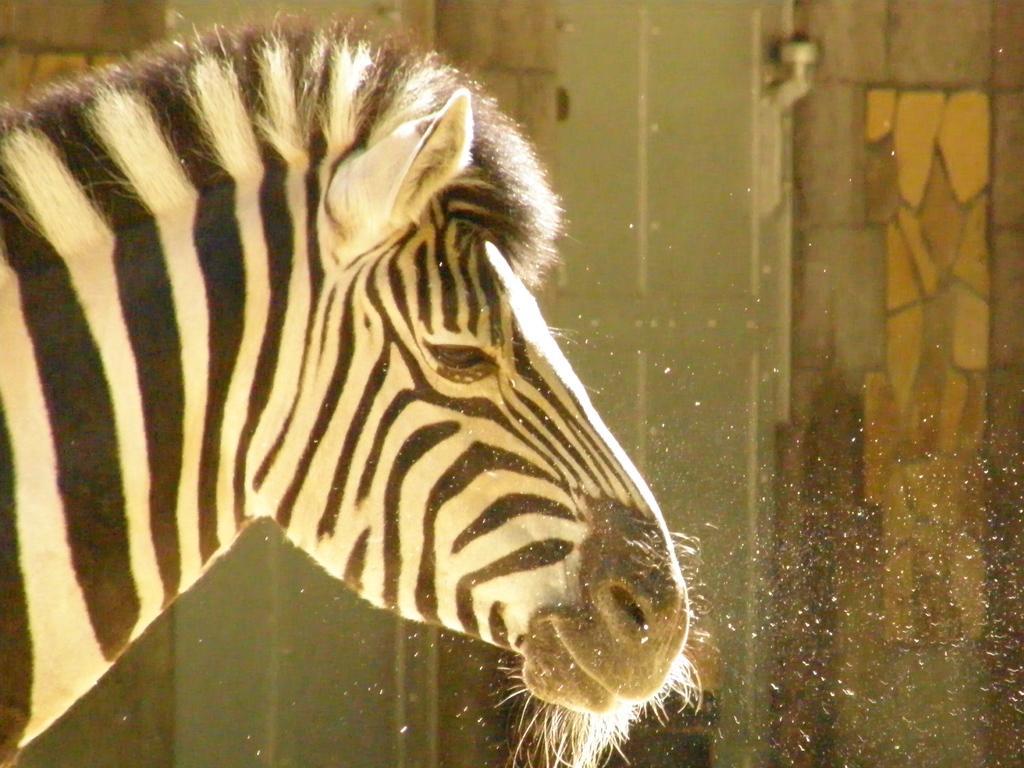Describe this image in one or two sentences. In the picture we can see face of a zebra. 